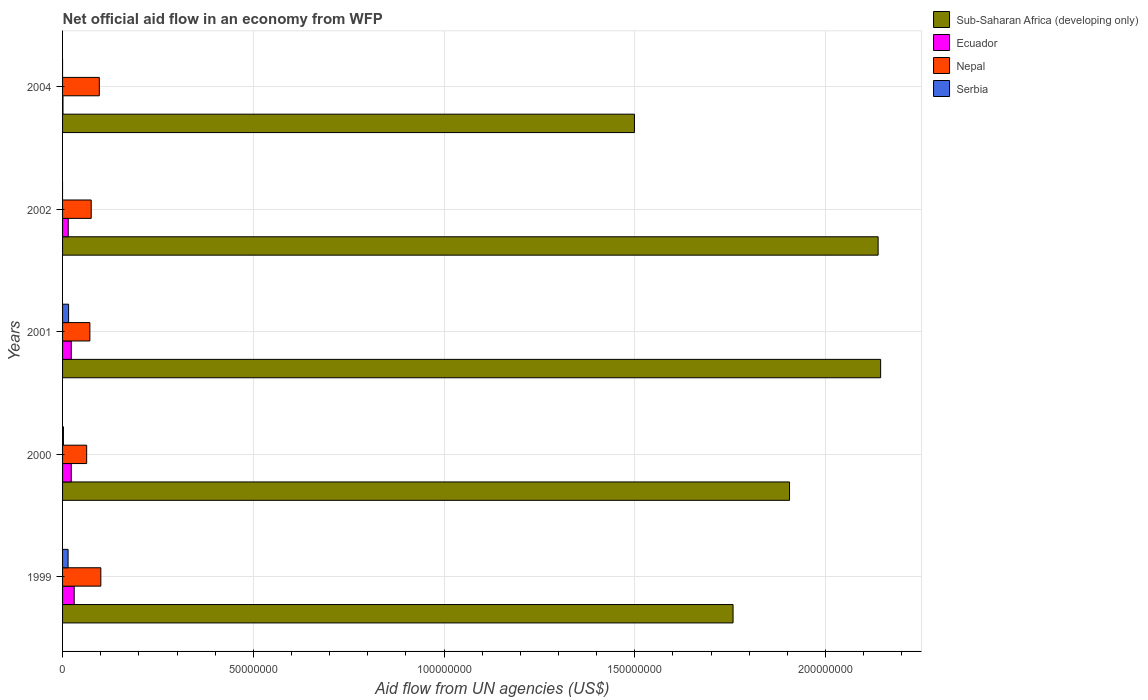What is the label of the 5th group of bars from the top?
Offer a terse response. 1999. In how many cases, is the number of bars for a given year not equal to the number of legend labels?
Your answer should be very brief. 2. What is the net official aid flow in Nepal in 1999?
Provide a succinct answer. 1.00e+07. Across all years, what is the maximum net official aid flow in Serbia?
Ensure brevity in your answer.  1.58e+06. Across all years, what is the minimum net official aid flow in Sub-Saharan Africa (developing only)?
Keep it short and to the point. 1.50e+08. In which year was the net official aid flow in Serbia maximum?
Make the answer very short. 2001. What is the total net official aid flow in Sub-Saharan Africa (developing only) in the graph?
Keep it short and to the point. 9.44e+08. What is the difference between the net official aid flow in Nepal in 2002 and that in 2004?
Your answer should be very brief. -2.12e+06. What is the difference between the net official aid flow in Sub-Saharan Africa (developing only) in 1999 and the net official aid flow in Serbia in 2002?
Your answer should be very brief. 1.76e+08. What is the average net official aid flow in Serbia per year?
Offer a terse response. 6.52e+05. In the year 1999, what is the difference between the net official aid flow in Ecuador and net official aid flow in Serbia?
Offer a terse response. 1.60e+06. In how many years, is the net official aid flow in Ecuador greater than 200000000 US$?
Offer a very short reply. 0. What is the ratio of the net official aid flow in Sub-Saharan Africa (developing only) in 1999 to that in 2001?
Make the answer very short. 0.82. Is the net official aid flow in Sub-Saharan Africa (developing only) in 1999 less than that in 2001?
Ensure brevity in your answer.  Yes. Is the difference between the net official aid flow in Ecuador in 2000 and 2001 greater than the difference between the net official aid flow in Serbia in 2000 and 2001?
Offer a terse response. Yes. What is the difference between the highest and the second highest net official aid flow in Ecuador?
Your answer should be very brief. 7.70e+05. What is the difference between the highest and the lowest net official aid flow in Sub-Saharan Africa (developing only)?
Your response must be concise. 6.45e+07. Is it the case that in every year, the sum of the net official aid flow in Nepal and net official aid flow in Sub-Saharan Africa (developing only) is greater than the sum of net official aid flow in Serbia and net official aid flow in Ecuador?
Ensure brevity in your answer.  Yes. How many bars are there?
Your response must be concise. 18. Are all the bars in the graph horizontal?
Your response must be concise. Yes. How many years are there in the graph?
Provide a short and direct response. 5. Are the values on the major ticks of X-axis written in scientific E-notation?
Ensure brevity in your answer.  No. Does the graph contain any zero values?
Give a very brief answer. Yes. Does the graph contain grids?
Provide a succinct answer. Yes. How many legend labels are there?
Make the answer very short. 4. What is the title of the graph?
Ensure brevity in your answer.  Net official aid flow in an economy from WFP. What is the label or title of the X-axis?
Your response must be concise. Aid flow from UN agencies (US$). What is the label or title of the Y-axis?
Give a very brief answer. Years. What is the Aid flow from UN agencies (US$) in Sub-Saharan Africa (developing only) in 1999?
Ensure brevity in your answer.  1.76e+08. What is the Aid flow from UN agencies (US$) in Ecuador in 1999?
Your answer should be very brief. 3.05e+06. What is the Aid flow from UN agencies (US$) of Nepal in 1999?
Make the answer very short. 1.00e+07. What is the Aid flow from UN agencies (US$) in Serbia in 1999?
Make the answer very short. 1.45e+06. What is the Aid flow from UN agencies (US$) in Sub-Saharan Africa (developing only) in 2000?
Keep it short and to the point. 1.91e+08. What is the Aid flow from UN agencies (US$) in Ecuador in 2000?
Keep it short and to the point. 2.28e+06. What is the Aid flow from UN agencies (US$) of Nepal in 2000?
Give a very brief answer. 6.32e+06. What is the Aid flow from UN agencies (US$) in Serbia in 2000?
Offer a very short reply. 2.30e+05. What is the Aid flow from UN agencies (US$) in Sub-Saharan Africa (developing only) in 2001?
Offer a terse response. 2.14e+08. What is the Aid flow from UN agencies (US$) in Ecuador in 2001?
Offer a terse response. 2.28e+06. What is the Aid flow from UN agencies (US$) in Nepal in 2001?
Offer a very short reply. 7.16e+06. What is the Aid flow from UN agencies (US$) in Serbia in 2001?
Provide a short and direct response. 1.58e+06. What is the Aid flow from UN agencies (US$) of Sub-Saharan Africa (developing only) in 2002?
Ensure brevity in your answer.  2.14e+08. What is the Aid flow from UN agencies (US$) in Ecuador in 2002?
Your answer should be compact. 1.49e+06. What is the Aid flow from UN agencies (US$) in Nepal in 2002?
Ensure brevity in your answer.  7.51e+06. What is the Aid flow from UN agencies (US$) in Serbia in 2002?
Your answer should be very brief. 0. What is the Aid flow from UN agencies (US$) of Sub-Saharan Africa (developing only) in 2004?
Offer a terse response. 1.50e+08. What is the Aid flow from UN agencies (US$) of Ecuador in 2004?
Provide a short and direct response. 1.10e+05. What is the Aid flow from UN agencies (US$) in Nepal in 2004?
Your answer should be very brief. 9.63e+06. What is the Aid flow from UN agencies (US$) of Serbia in 2004?
Your answer should be very brief. 0. Across all years, what is the maximum Aid flow from UN agencies (US$) of Sub-Saharan Africa (developing only)?
Provide a short and direct response. 2.14e+08. Across all years, what is the maximum Aid flow from UN agencies (US$) in Ecuador?
Give a very brief answer. 3.05e+06. Across all years, what is the maximum Aid flow from UN agencies (US$) of Nepal?
Your response must be concise. 1.00e+07. Across all years, what is the maximum Aid flow from UN agencies (US$) in Serbia?
Ensure brevity in your answer.  1.58e+06. Across all years, what is the minimum Aid flow from UN agencies (US$) of Sub-Saharan Africa (developing only)?
Ensure brevity in your answer.  1.50e+08. Across all years, what is the minimum Aid flow from UN agencies (US$) of Ecuador?
Your answer should be compact. 1.10e+05. Across all years, what is the minimum Aid flow from UN agencies (US$) of Nepal?
Give a very brief answer. 6.32e+06. Across all years, what is the minimum Aid flow from UN agencies (US$) of Serbia?
Provide a succinct answer. 0. What is the total Aid flow from UN agencies (US$) in Sub-Saharan Africa (developing only) in the graph?
Provide a short and direct response. 9.44e+08. What is the total Aid flow from UN agencies (US$) in Ecuador in the graph?
Keep it short and to the point. 9.21e+06. What is the total Aid flow from UN agencies (US$) in Nepal in the graph?
Offer a very short reply. 4.06e+07. What is the total Aid flow from UN agencies (US$) of Serbia in the graph?
Give a very brief answer. 3.26e+06. What is the difference between the Aid flow from UN agencies (US$) in Sub-Saharan Africa (developing only) in 1999 and that in 2000?
Give a very brief answer. -1.48e+07. What is the difference between the Aid flow from UN agencies (US$) in Ecuador in 1999 and that in 2000?
Make the answer very short. 7.70e+05. What is the difference between the Aid flow from UN agencies (US$) of Nepal in 1999 and that in 2000?
Your answer should be compact. 3.71e+06. What is the difference between the Aid flow from UN agencies (US$) of Serbia in 1999 and that in 2000?
Provide a succinct answer. 1.22e+06. What is the difference between the Aid flow from UN agencies (US$) in Sub-Saharan Africa (developing only) in 1999 and that in 2001?
Provide a succinct answer. -3.87e+07. What is the difference between the Aid flow from UN agencies (US$) in Ecuador in 1999 and that in 2001?
Provide a succinct answer. 7.70e+05. What is the difference between the Aid flow from UN agencies (US$) in Nepal in 1999 and that in 2001?
Ensure brevity in your answer.  2.87e+06. What is the difference between the Aid flow from UN agencies (US$) in Sub-Saharan Africa (developing only) in 1999 and that in 2002?
Keep it short and to the point. -3.80e+07. What is the difference between the Aid flow from UN agencies (US$) in Ecuador in 1999 and that in 2002?
Give a very brief answer. 1.56e+06. What is the difference between the Aid flow from UN agencies (US$) of Nepal in 1999 and that in 2002?
Keep it short and to the point. 2.52e+06. What is the difference between the Aid flow from UN agencies (US$) in Sub-Saharan Africa (developing only) in 1999 and that in 2004?
Provide a succinct answer. 2.58e+07. What is the difference between the Aid flow from UN agencies (US$) in Ecuador in 1999 and that in 2004?
Offer a very short reply. 2.94e+06. What is the difference between the Aid flow from UN agencies (US$) of Sub-Saharan Africa (developing only) in 2000 and that in 2001?
Offer a terse response. -2.39e+07. What is the difference between the Aid flow from UN agencies (US$) in Ecuador in 2000 and that in 2001?
Provide a succinct answer. 0. What is the difference between the Aid flow from UN agencies (US$) in Nepal in 2000 and that in 2001?
Your answer should be compact. -8.40e+05. What is the difference between the Aid flow from UN agencies (US$) in Serbia in 2000 and that in 2001?
Provide a short and direct response. -1.35e+06. What is the difference between the Aid flow from UN agencies (US$) of Sub-Saharan Africa (developing only) in 2000 and that in 2002?
Give a very brief answer. -2.32e+07. What is the difference between the Aid flow from UN agencies (US$) of Ecuador in 2000 and that in 2002?
Offer a very short reply. 7.90e+05. What is the difference between the Aid flow from UN agencies (US$) of Nepal in 2000 and that in 2002?
Give a very brief answer. -1.19e+06. What is the difference between the Aid flow from UN agencies (US$) in Sub-Saharan Africa (developing only) in 2000 and that in 2004?
Your response must be concise. 4.06e+07. What is the difference between the Aid flow from UN agencies (US$) in Ecuador in 2000 and that in 2004?
Keep it short and to the point. 2.17e+06. What is the difference between the Aid flow from UN agencies (US$) of Nepal in 2000 and that in 2004?
Your answer should be very brief. -3.31e+06. What is the difference between the Aid flow from UN agencies (US$) of Ecuador in 2001 and that in 2002?
Provide a short and direct response. 7.90e+05. What is the difference between the Aid flow from UN agencies (US$) in Nepal in 2001 and that in 2002?
Offer a very short reply. -3.50e+05. What is the difference between the Aid flow from UN agencies (US$) in Sub-Saharan Africa (developing only) in 2001 and that in 2004?
Provide a succinct answer. 6.45e+07. What is the difference between the Aid flow from UN agencies (US$) in Ecuador in 2001 and that in 2004?
Provide a succinct answer. 2.17e+06. What is the difference between the Aid flow from UN agencies (US$) of Nepal in 2001 and that in 2004?
Give a very brief answer. -2.47e+06. What is the difference between the Aid flow from UN agencies (US$) of Sub-Saharan Africa (developing only) in 2002 and that in 2004?
Keep it short and to the point. 6.39e+07. What is the difference between the Aid flow from UN agencies (US$) of Ecuador in 2002 and that in 2004?
Your response must be concise. 1.38e+06. What is the difference between the Aid flow from UN agencies (US$) of Nepal in 2002 and that in 2004?
Ensure brevity in your answer.  -2.12e+06. What is the difference between the Aid flow from UN agencies (US$) of Sub-Saharan Africa (developing only) in 1999 and the Aid flow from UN agencies (US$) of Ecuador in 2000?
Keep it short and to the point. 1.73e+08. What is the difference between the Aid flow from UN agencies (US$) in Sub-Saharan Africa (developing only) in 1999 and the Aid flow from UN agencies (US$) in Nepal in 2000?
Provide a succinct answer. 1.69e+08. What is the difference between the Aid flow from UN agencies (US$) in Sub-Saharan Africa (developing only) in 1999 and the Aid flow from UN agencies (US$) in Serbia in 2000?
Your response must be concise. 1.76e+08. What is the difference between the Aid flow from UN agencies (US$) in Ecuador in 1999 and the Aid flow from UN agencies (US$) in Nepal in 2000?
Keep it short and to the point. -3.27e+06. What is the difference between the Aid flow from UN agencies (US$) in Ecuador in 1999 and the Aid flow from UN agencies (US$) in Serbia in 2000?
Provide a succinct answer. 2.82e+06. What is the difference between the Aid flow from UN agencies (US$) in Nepal in 1999 and the Aid flow from UN agencies (US$) in Serbia in 2000?
Your answer should be very brief. 9.80e+06. What is the difference between the Aid flow from UN agencies (US$) in Sub-Saharan Africa (developing only) in 1999 and the Aid flow from UN agencies (US$) in Ecuador in 2001?
Your answer should be compact. 1.73e+08. What is the difference between the Aid flow from UN agencies (US$) of Sub-Saharan Africa (developing only) in 1999 and the Aid flow from UN agencies (US$) of Nepal in 2001?
Your answer should be very brief. 1.69e+08. What is the difference between the Aid flow from UN agencies (US$) in Sub-Saharan Africa (developing only) in 1999 and the Aid flow from UN agencies (US$) in Serbia in 2001?
Offer a terse response. 1.74e+08. What is the difference between the Aid flow from UN agencies (US$) in Ecuador in 1999 and the Aid flow from UN agencies (US$) in Nepal in 2001?
Provide a short and direct response. -4.11e+06. What is the difference between the Aid flow from UN agencies (US$) of Ecuador in 1999 and the Aid flow from UN agencies (US$) of Serbia in 2001?
Your answer should be compact. 1.47e+06. What is the difference between the Aid flow from UN agencies (US$) of Nepal in 1999 and the Aid flow from UN agencies (US$) of Serbia in 2001?
Your response must be concise. 8.45e+06. What is the difference between the Aid flow from UN agencies (US$) in Sub-Saharan Africa (developing only) in 1999 and the Aid flow from UN agencies (US$) in Ecuador in 2002?
Provide a succinct answer. 1.74e+08. What is the difference between the Aid flow from UN agencies (US$) in Sub-Saharan Africa (developing only) in 1999 and the Aid flow from UN agencies (US$) in Nepal in 2002?
Your response must be concise. 1.68e+08. What is the difference between the Aid flow from UN agencies (US$) in Ecuador in 1999 and the Aid flow from UN agencies (US$) in Nepal in 2002?
Offer a terse response. -4.46e+06. What is the difference between the Aid flow from UN agencies (US$) of Sub-Saharan Africa (developing only) in 1999 and the Aid flow from UN agencies (US$) of Ecuador in 2004?
Give a very brief answer. 1.76e+08. What is the difference between the Aid flow from UN agencies (US$) of Sub-Saharan Africa (developing only) in 1999 and the Aid flow from UN agencies (US$) of Nepal in 2004?
Provide a short and direct response. 1.66e+08. What is the difference between the Aid flow from UN agencies (US$) in Ecuador in 1999 and the Aid flow from UN agencies (US$) in Nepal in 2004?
Offer a terse response. -6.58e+06. What is the difference between the Aid flow from UN agencies (US$) of Sub-Saharan Africa (developing only) in 2000 and the Aid flow from UN agencies (US$) of Ecuador in 2001?
Ensure brevity in your answer.  1.88e+08. What is the difference between the Aid flow from UN agencies (US$) in Sub-Saharan Africa (developing only) in 2000 and the Aid flow from UN agencies (US$) in Nepal in 2001?
Keep it short and to the point. 1.83e+08. What is the difference between the Aid flow from UN agencies (US$) in Sub-Saharan Africa (developing only) in 2000 and the Aid flow from UN agencies (US$) in Serbia in 2001?
Your answer should be compact. 1.89e+08. What is the difference between the Aid flow from UN agencies (US$) in Ecuador in 2000 and the Aid flow from UN agencies (US$) in Nepal in 2001?
Your response must be concise. -4.88e+06. What is the difference between the Aid flow from UN agencies (US$) of Nepal in 2000 and the Aid flow from UN agencies (US$) of Serbia in 2001?
Your response must be concise. 4.74e+06. What is the difference between the Aid flow from UN agencies (US$) of Sub-Saharan Africa (developing only) in 2000 and the Aid flow from UN agencies (US$) of Ecuador in 2002?
Ensure brevity in your answer.  1.89e+08. What is the difference between the Aid flow from UN agencies (US$) in Sub-Saharan Africa (developing only) in 2000 and the Aid flow from UN agencies (US$) in Nepal in 2002?
Provide a short and direct response. 1.83e+08. What is the difference between the Aid flow from UN agencies (US$) of Ecuador in 2000 and the Aid flow from UN agencies (US$) of Nepal in 2002?
Provide a succinct answer. -5.23e+06. What is the difference between the Aid flow from UN agencies (US$) of Sub-Saharan Africa (developing only) in 2000 and the Aid flow from UN agencies (US$) of Ecuador in 2004?
Your response must be concise. 1.90e+08. What is the difference between the Aid flow from UN agencies (US$) in Sub-Saharan Africa (developing only) in 2000 and the Aid flow from UN agencies (US$) in Nepal in 2004?
Offer a very short reply. 1.81e+08. What is the difference between the Aid flow from UN agencies (US$) of Ecuador in 2000 and the Aid flow from UN agencies (US$) of Nepal in 2004?
Your response must be concise. -7.35e+06. What is the difference between the Aid flow from UN agencies (US$) in Sub-Saharan Africa (developing only) in 2001 and the Aid flow from UN agencies (US$) in Ecuador in 2002?
Your response must be concise. 2.13e+08. What is the difference between the Aid flow from UN agencies (US$) of Sub-Saharan Africa (developing only) in 2001 and the Aid flow from UN agencies (US$) of Nepal in 2002?
Give a very brief answer. 2.07e+08. What is the difference between the Aid flow from UN agencies (US$) in Ecuador in 2001 and the Aid flow from UN agencies (US$) in Nepal in 2002?
Offer a terse response. -5.23e+06. What is the difference between the Aid flow from UN agencies (US$) of Sub-Saharan Africa (developing only) in 2001 and the Aid flow from UN agencies (US$) of Ecuador in 2004?
Offer a terse response. 2.14e+08. What is the difference between the Aid flow from UN agencies (US$) of Sub-Saharan Africa (developing only) in 2001 and the Aid flow from UN agencies (US$) of Nepal in 2004?
Your answer should be compact. 2.05e+08. What is the difference between the Aid flow from UN agencies (US$) of Ecuador in 2001 and the Aid flow from UN agencies (US$) of Nepal in 2004?
Give a very brief answer. -7.35e+06. What is the difference between the Aid flow from UN agencies (US$) of Sub-Saharan Africa (developing only) in 2002 and the Aid flow from UN agencies (US$) of Ecuador in 2004?
Offer a terse response. 2.14e+08. What is the difference between the Aid flow from UN agencies (US$) in Sub-Saharan Africa (developing only) in 2002 and the Aid flow from UN agencies (US$) in Nepal in 2004?
Provide a short and direct response. 2.04e+08. What is the difference between the Aid flow from UN agencies (US$) in Ecuador in 2002 and the Aid flow from UN agencies (US$) in Nepal in 2004?
Ensure brevity in your answer.  -8.14e+06. What is the average Aid flow from UN agencies (US$) in Sub-Saharan Africa (developing only) per year?
Your answer should be very brief. 1.89e+08. What is the average Aid flow from UN agencies (US$) of Ecuador per year?
Provide a succinct answer. 1.84e+06. What is the average Aid flow from UN agencies (US$) of Nepal per year?
Make the answer very short. 8.13e+06. What is the average Aid flow from UN agencies (US$) of Serbia per year?
Ensure brevity in your answer.  6.52e+05. In the year 1999, what is the difference between the Aid flow from UN agencies (US$) in Sub-Saharan Africa (developing only) and Aid flow from UN agencies (US$) in Ecuador?
Keep it short and to the point. 1.73e+08. In the year 1999, what is the difference between the Aid flow from UN agencies (US$) of Sub-Saharan Africa (developing only) and Aid flow from UN agencies (US$) of Nepal?
Offer a very short reply. 1.66e+08. In the year 1999, what is the difference between the Aid flow from UN agencies (US$) of Sub-Saharan Africa (developing only) and Aid flow from UN agencies (US$) of Serbia?
Ensure brevity in your answer.  1.74e+08. In the year 1999, what is the difference between the Aid flow from UN agencies (US$) of Ecuador and Aid flow from UN agencies (US$) of Nepal?
Provide a succinct answer. -6.98e+06. In the year 1999, what is the difference between the Aid flow from UN agencies (US$) of Ecuador and Aid flow from UN agencies (US$) of Serbia?
Offer a terse response. 1.60e+06. In the year 1999, what is the difference between the Aid flow from UN agencies (US$) in Nepal and Aid flow from UN agencies (US$) in Serbia?
Provide a short and direct response. 8.58e+06. In the year 2000, what is the difference between the Aid flow from UN agencies (US$) in Sub-Saharan Africa (developing only) and Aid flow from UN agencies (US$) in Ecuador?
Your response must be concise. 1.88e+08. In the year 2000, what is the difference between the Aid flow from UN agencies (US$) of Sub-Saharan Africa (developing only) and Aid flow from UN agencies (US$) of Nepal?
Ensure brevity in your answer.  1.84e+08. In the year 2000, what is the difference between the Aid flow from UN agencies (US$) of Sub-Saharan Africa (developing only) and Aid flow from UN agencies (US$) of Serbia?
Offer a very short reply. 1.90e+08. In the year 2000, what is the difference between the Aid flow from UN agencies (US$) of Ecuador and Aid flow from UN agencies (US$) of Nepal?
Provide a short and direct response. -4.04e+06. In the year 2000, what is the difference between the Aid flow from UN agencies (US$) in Ecuador and Aid flow from UN agencies (US$) in Serbia?
Keep it short and to the point. 2.05e+06. In the year 2000, what is the difference between the Aid flow from UN agencies (US$) of Nepal and Aid flow from UN agencies (US$) of Serbia?
Provide a succinct answer. 6.09e+06. In the year 2001, what is the difference between the Aid flow from UN agencies (US$) in Sub-Saharan Africa (developing only) and Aid flow from UN agencies (US$) in Ecuador?
Offer a very short reply. 2.12e+08. In the year 2001, what is the difference between the Aid flow from UN agencies (US$) of Sub-Saharan Africa (developing only) and Aid flow from UN agencies (US$) of Nepal?
Provide a succinct answer. 2.07e+08. In the year 2001, what is the difference between the Aid flow from UN agencies (US$) of Sub-Saharan Africa (developing only) and Aid flow from UN agencies (US$) of Serbia?
Keep it short and to the point. 2.13e+08. In the year 2001, what is the difference between the Aid flow from UN agencies (US$) in Ecuador and Aid flow from UN agencies (US$) in Nepal?
Make the answer very short. -4.88e+06. In the year 2001, what is the difference between the Aid flow from UN agencies (US$) of Ecuador and Aid flow from UN agencies (US$) of Serbia?
Provide a short and direct response. 7.00e+05. In the year 2001, what is the difference between the Aid flow from UN agencies (US$) in Nepal and Aid flow from UN agencies (US$) in Serbia?
Your response must be concise. 5.58e+06. In the year 2002, what is the difference between the Aid flow from UN agencies (US$) in Sub-Saharan Africa (developing only) and Aid flow from UN agencies (US$) in Ecuador?
Ensure brevity in your answer.  2.12e+08. In the year 2002, what is the difference between the Aid flow from UN agencies (US$) of Sub-Saharan Africa (developing only) and Aid flow from UN agencies (US$) of Nepal?
Offer a very short reply. 2.06e+08. In the year 2002, what is the difference between the Aid flow from UN agencies (US$) in Ecuador and Aid flow from UN agencies (US$) in Nepal?
Your response must be concise. -6.02e+06. In the year 2004, what is the difference between the Aid flow from UN agencies (US$) of Sub-Saharan Africa (developing only) and Aid flow from UN agencies (US$) of Ecuador?
Make the answer very short. 1.50e+08. In the year 2004, what is the difference between the Aid flow from UN agencies (US$) of Sub-Saharan Africa (developing only) and Aid flow from UN agencies (US$) of Nepal?
Ensure brevity in your answer.  1.40e+08. In the year 2004, what is the difference between the Aid flow from UN agencies (US$) in Ecuador and Aid flow from UN agencies (US$) in Nepal?
Give a very brief answer. -9.52e+06. What is the ratio of the Aid flow from UN agencies (US$) in Sub-Saharan Africa (developing only) in 1999 to that in 2000?
Offer a very short reply. 0.92. What is the ratio of the Aid flow from UN agencies (US$) of Ecuador in 1999 to that in 2000?
Ensure brevity in your answer.  1.34. What is the ratio of the Aid flow from UN agencies (US$) in Nepal in 1999 to that in 2000?
Provide a succinct answer. 1.59. What is the ratio of the Aid flow from UN agencies (US$) in Serbia in 1999 to that in 2000?
Provide a succinct answer. 6.3. What is the ratio of the Aid flow from UN agencies (US$) in Sub-Saharan Africa (developing only) in 1999 to that in 2001?
Give a very brief answer. 0.82. What is the ratio of the Aid flow from UN agencies (US$) in Ecuador in 1999 to that in 2001?
Your answer should be compact. 1.34. What is the ratio of the Aid flow from UN agencies (US$) in Nepal in 1999 to that in 2001?
Ensure brevity in your answer.  1.4. What is the ratio of the Aid flow from UN agencies (US$) of Serbia in 1999 to that in 2001?
Keep it short and to the point. 0.92. What is the ratio of the Aid flow from UN agencies (US$) in Sub-Saharan Africa (developing only) in 1999 to that in 2002?
Your answer should be compact. 0.82. What is the ratio of the Aid flow from UN agencies (US$) in Ecuador in 1999 to that in 2002?
Your response must be concise. 2.05. What is the ratio of the Aid flow from UN agencies (US$) of Nepal in 1999 to that in 2002?
Keep it short and to the point. 1.34. What is the ratio of the Aid flow from UN agencies (US$) in Sub-Saharan Africa (developing only) in 1999 to that in 2004?
Your answer should be compact. 1.17. What is the ratio of the Aid flow from UN agencies (US$) of Ecuador in 1999 to that in 2004?
Give a very brief answer. 27.73. What is the ratio of the Aid flow from UN agencies (US$) of Nepal in 1999 to that in 2004?
Your answer should be very brief. 1.04. What is the ratio of the Aid flow from UN agencies (US$) in Sub-Saharan Africa (developing only) in 2000 to that in 2001?
Your answer should be very brief. 0.89. What is the ratio of the Aid flow from UN agencies (US$) in Nepal in 2000 to that in 2001?
Provide a short and direct response. 0.88. What is the ratio of the Aid flow from UN agencies (US$) in Serbia in 2000 to that in 2001?
Give a very brief answer. 0.15. What is the ratio of the Aid flow from UN agencies (US$) in Sub-Saharan Africa (developing only) in 2000 to that in 2002?
Offer a terse response. 0.89. What is the ratio of the Aid flow from UN agencies (US$) in Ecuador in 2000 to that in 2002?
Keep it short and to the point. 1.53. What is the ratio of the Aid flow from UN agencies (US$) in Nepal in 2000 to that in 2002?
Offer a terse response. 0.84. What is the ratio of the Aid flow from UN agencies (US$) of Sub-Saharan Africa (developing only) in 2000 to that in 2004?
Provide a short and direct response. 1.27. What is the ratio of the Aid flow from UN agencies (US$) in Ecuador in 2000 to that in 2004?
Your answer should be compact. 20.73. What is the ratio of the Aid flow from UN agencies (US$) in Nepal in 2000 to that in 2004?
Make the answer very short. 0.66. What is the ratio of the Aid flow from UN agencies (US$) of Ecuador in 2001 to that in 2002?
Provide a succinct answer. 1.53. What is the ratio of the Aid flow from UN agencies (US$) of Nepal in 2001 to that in 2002?
Offer a terse response. 0.95. What is the ratio of the Aid flow from UN agencies (US$) in Sub-Saharan Africa (developing only) in 2001 to that in 2004?
Your answer should be compact. 1.43. What is the ratio of the Aid flow from UN agencies (US$) of Ecuador in 2001 to that in 2004?
Offer a very short reply. 20.73. What is the ratio of the Aid flow from UN agencies (US$) of Nepal in 2001 to that in 2004?
Provide a short and direct response. 0.74. What is the ratio of the Aid flow from UN agencies (US$) of Sub-Saharan Africa (developing only) in 2002 to that in 2004?
Provide a short and direct response. 1.43. What is the ratio of the Aid flow from UN agencies (US$) in Ecuador in 2002 to that in 2004?
Give a very brief answer. 13.55. What is the ratio of the Aid flow from UN agencies (US$) of Nepal in 2002 to that in 2004?
Ensure brevity in your answer.  0.78. What is the difference between the highest and the second highest Aid flow from UN agencies (US$) of Sub-Saharan Africa (developing only)?
Provide a succinct answer. 6.60e+05. What is the difference between the highest and the second highest Aid flow from UN agencies (US$) of Ecuador?
Provide a succinct answer. 7.70e+05. What is the difference between the highest and the second highest Aid flow from UN agencies (US$) in Nepal?
Make the answer very short. 4.00e+05. What is the difference between the highest and the second highest Aid flow from UN agencies (US$) in Serbia?
Provide a succinct answer. 1.30e+05. What is the difference between the highest and the lowest Aid flow from UN agencies (US$) in Sub-Saharan Africa (developing only)?
Offer a very short reply. 6.45e+07. What is the difference between the highest and the lowest Aid flow from UN agencies (US$) of Ecuador?
Ensure brevity in your answer.  2.94e+06. What is the difference between the highest and the lowest Aid flow from UN agencies (US$) of Nepal?
Keep it short and to the point. 3.71e+06. What is the difference between the highest and the lowest Aid flow from UN agencies (US$) in Serbia?
Your answer should be very brief. 1.58e+06. 